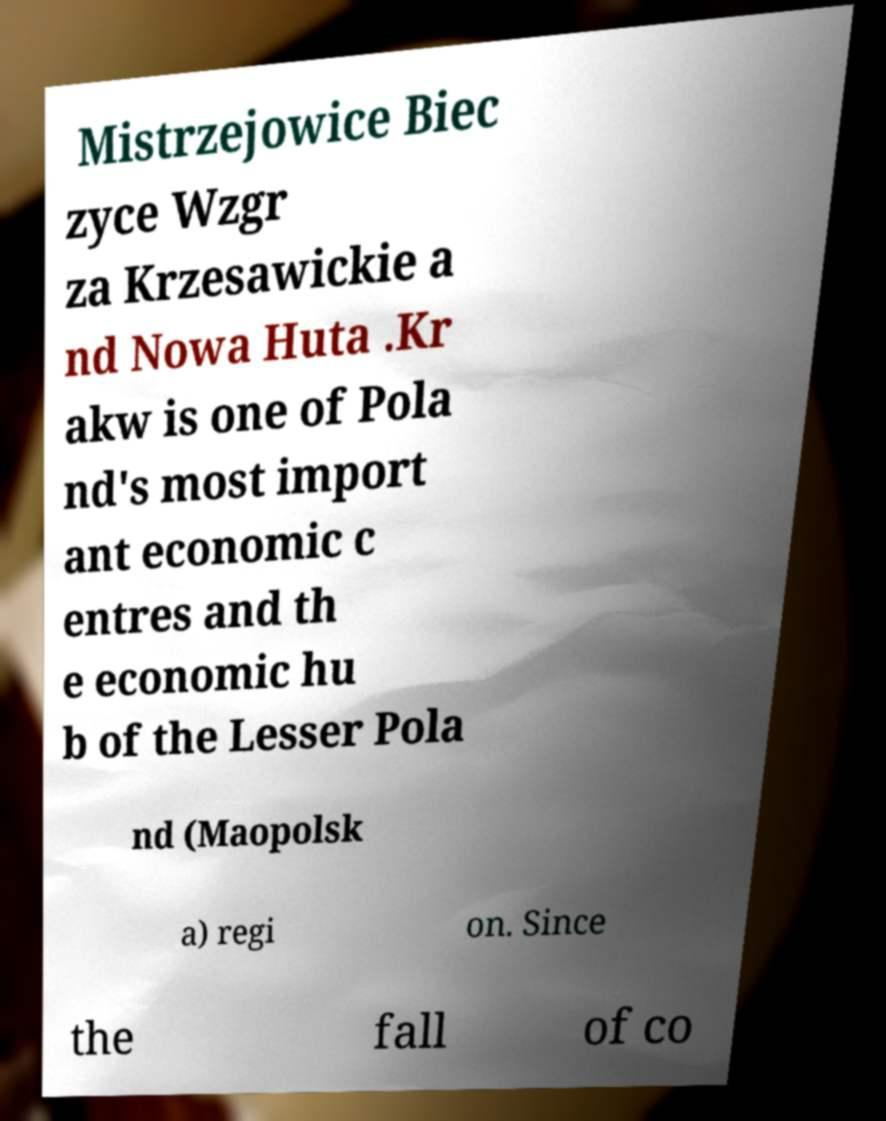For documentation purposes, I need the text within this image transcribed. Could you provide that? Mistrzejowice Biec zyce Wzgr za Krzesawickie a nd Nowa Huta .Kr akw is one of Pola nd's most import ant economic c entres and th e economic hu b of the Lesser Pola nd (Maopolsk a) regi on. Since the fall of co 